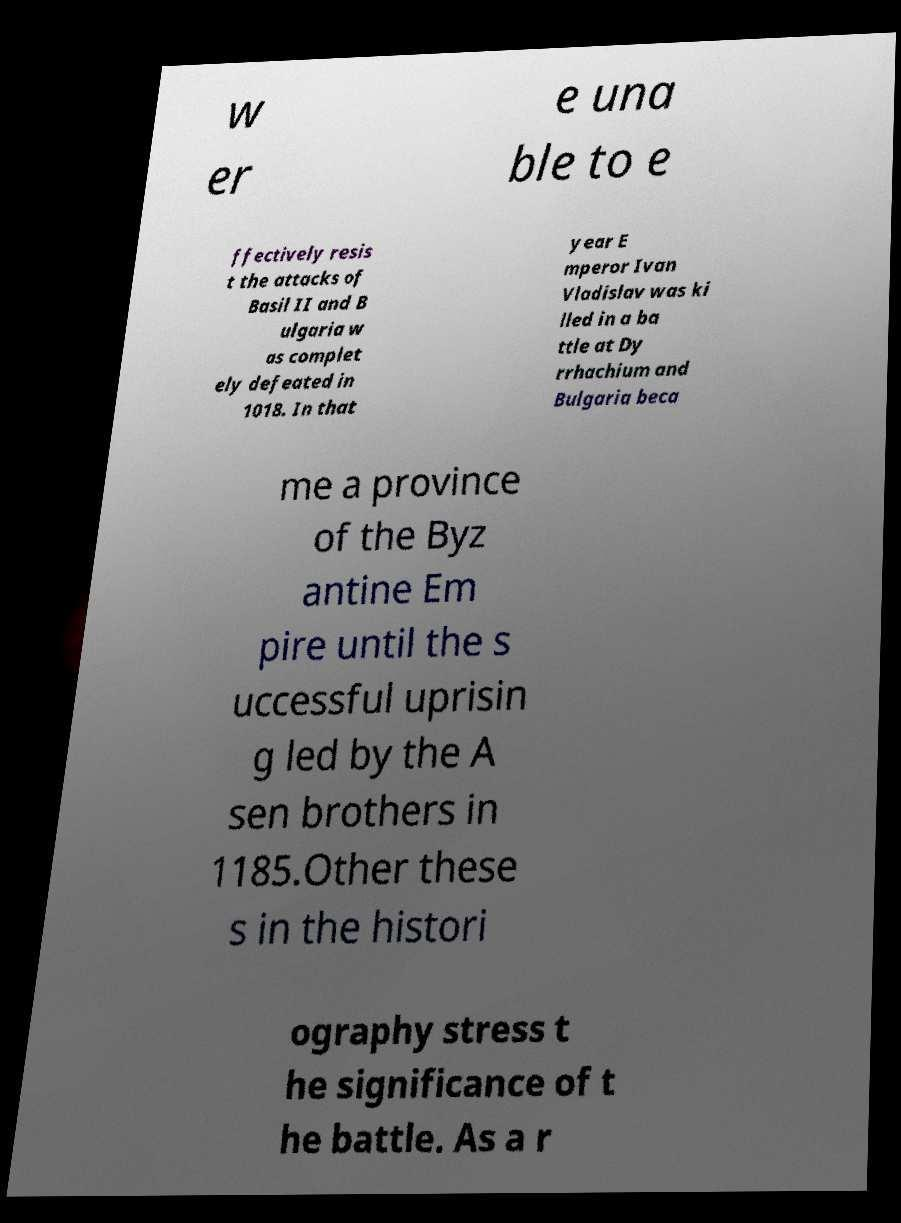I need the written content from this picture converted into text. Can you do that? w er e una ble to e ffectively resis t the attacks of Basil II and B ulgaria w as complet ely defeated in 1018. In that year E mperor Ivan Vladislav was ki lled in a ba ttle at Dy rrhachium and Bulgaria beca me a province of the Byz antine Em pire until the s uccessful uprisin g led by the A sen brothers in 1185.Other these s in the histori ography stress t he significance of t he battle. As a r 